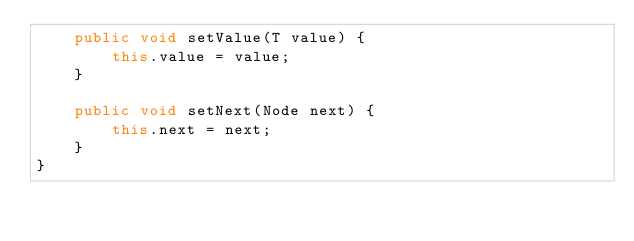<code> <loc_0><loc_0><loc_500><loc_500><_Java_>    public void setValue(T value) {
        this.value = value;
    }

    public void setNext(Node next) {
        this.next = next;
    }
}
</code> 